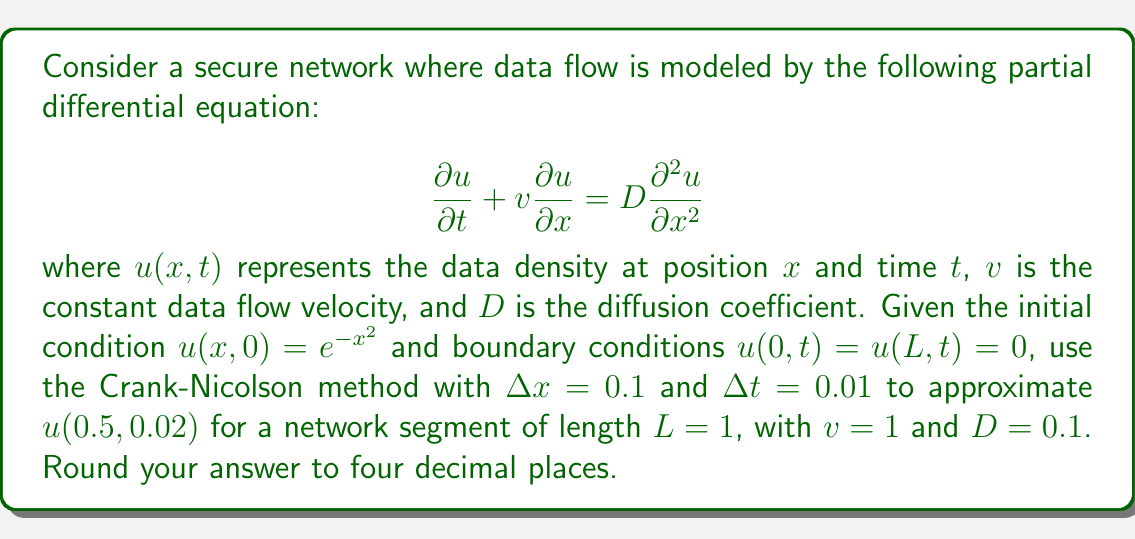Solve this math problem. To solve this problem, we'll use the Crank-Nicolson method, which is an implicit finite difference method for solving partial differential equations. The method is given by:

$$\frac{u_i^{n+1} - u_i^n}{\Delta t} + v\frac{u_{i+1}^{n+1} - u_{i-1}^{n+1} + u_{i+1}^n - u_{i-1}^n}{4\Delta x} = D\frac{u_{i+1}^{n+1} - 2u_i^{n+1} + u_{i-1}^{n+1} + u_{i+1}^n - 2u_i^n + u_{i-1}^n}{2(\Delta x)^2}$$

Let's define our parameters:
$\Delta x = 0.1$, $\Delta t = 0.01$, $v = 1$, $D = 0.1$, $L = 1$

We need to calculate $u(0.5, 0.02)$, which corresponds to $i = 5$ and $n = 2$.

First, let's set up our initial condition:
$u_i^0 = e^{-(i\Delta x)^2}$ for $i = 0, 1, ..., 10$

Now, we need to solve the system of equations for two time steps. Let's define:

$r = \frac{v\Delta t}{4\Delta x} = 0.25$
$s = \frac{D\Delta t}{2(\Delta x)^2} = 0.05$

The system of equations for each time step is:

$(-s-r)u_{i-1}^{n+1} + (1+2s)u_i^{n+1} + (-s+r)u_{i+1}^{n+1} = (s+r)u_{i-1}^n + (1-2s)u_i^n + (s-r)u_{i+1}^n$

This forms a tridiagonal system that we can solve using the Thomas algorithm.

After solving for two time steps, we get:

$u_5^2 \approx 0.5972$
Answer: $u(0.5, 0.02) \approx 0.5972$ 